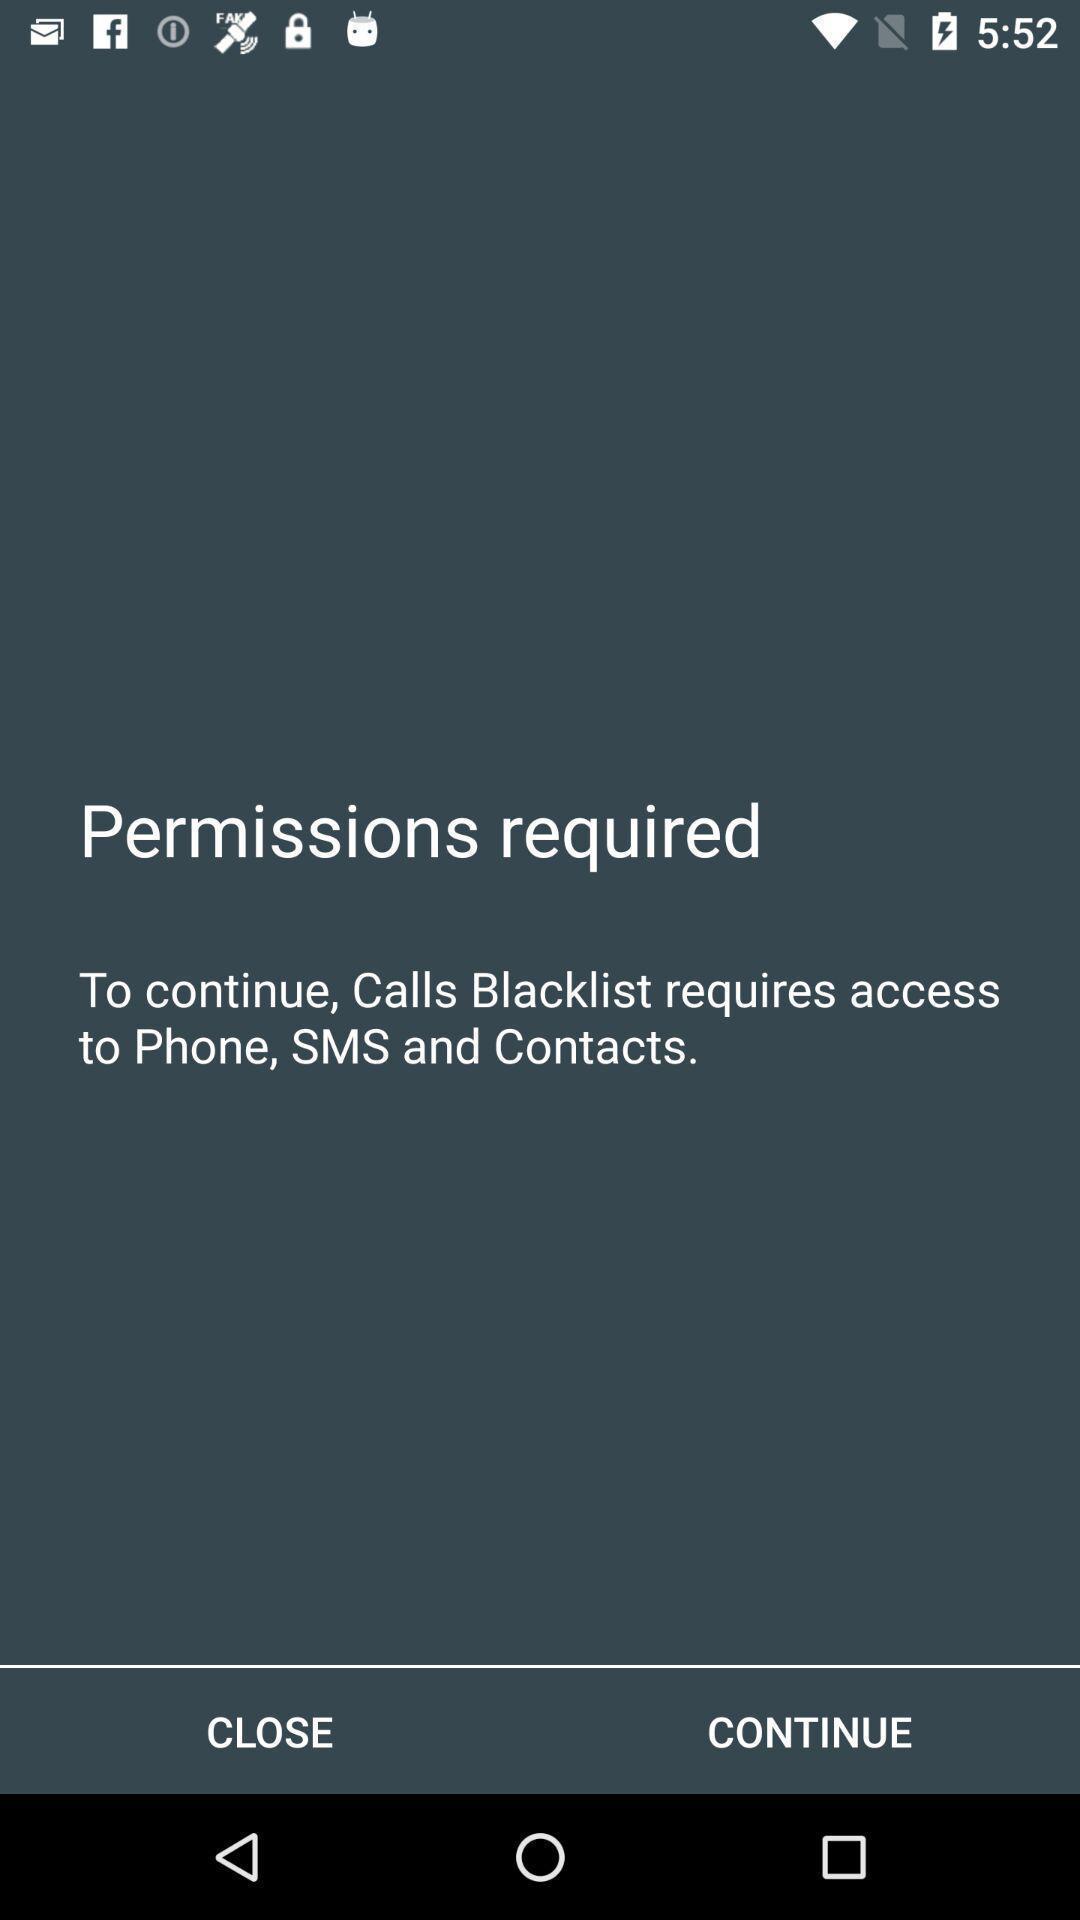Provide a description of this screenshot. Permissions are required to continue into a page. 